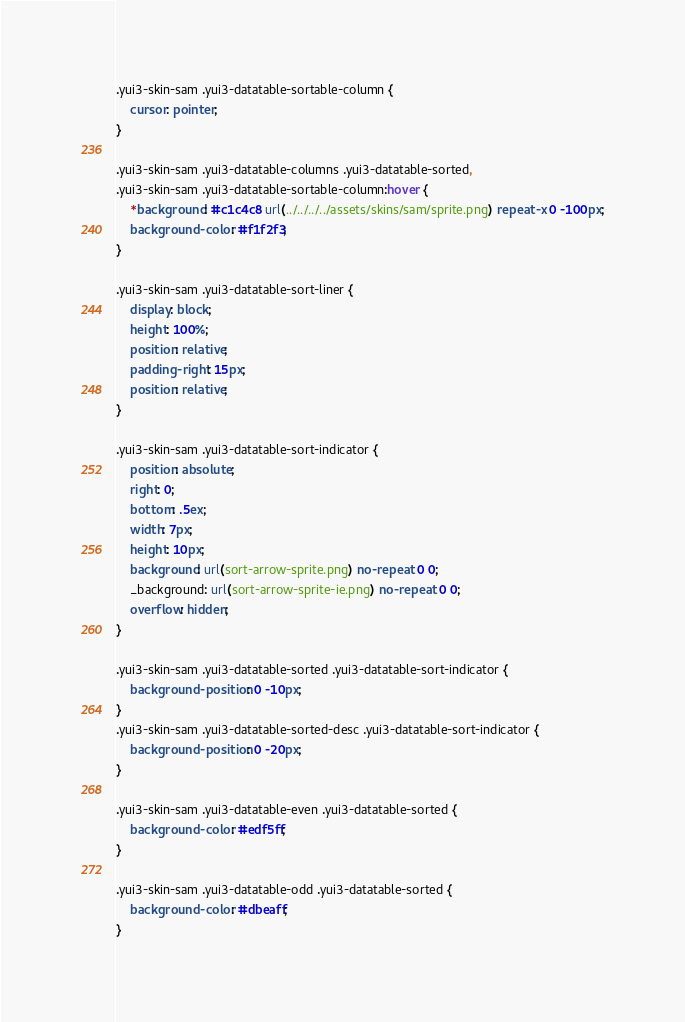Convert code to text. <code><loc_0><loc_0><loc_500><loc_500><_CSS_>.yui3-skin-sam .yui3-datatable-sortable-column {
    cursor: pointer;
}

.yui3-skin-sam .yui3-datatable-columns .yui3-datatable-sorted,
.yui3-skin-sam .yui3-datatable-sortable-column:hover {
    *background: #c1c4c8 url(../../../../assets/skins/sam/sprite.png) repeat-x 0 -100px;
    background-color: #f1f2f3;
}

.yui3-skin-sam .yui3-datatable-sort-liner {
    display: block;
    height: 100%;
    position: relative;
    padding-right: 15px;
    position: relative;
}

.yui3-skin-sam .yui3-datatable-sort-indicator {
    position: absolute;
    right: 0;
    bottom: .5ex;
    width: 7px;
    height: 10px;
    background: url(sort-arrow-sprite.png) no-repeat 0 0;
    _background: url(sort-arrow-sprite-ie.png) no-repeat 0 0;
    overflow: hidden;
}

.yui3-skin-sam .yui3-datatable-sorted .yui3-datatable-sort-indicator {
    background-position: 0 -10px;
}
.yui3-skin-sam .yui3-datatable-sorted-desc .yui3-datatable-sort-indicator {
    background-position: 0 -20px;
}

.yui3-skin-sam .yui3-datatable-even .yui3-datatable-sorted {
    background-color: #edf5ff;
}

.yui3-skin-sam .yui3-datatable-odd .yui3-datatable-sorted {
    background-color: #dbeaff;
}
</code> 